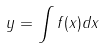Convert formula to latex. <formula><loc_0><loc_0><loc_500><loc_500>y = \int f ( x ) d x</formula> 